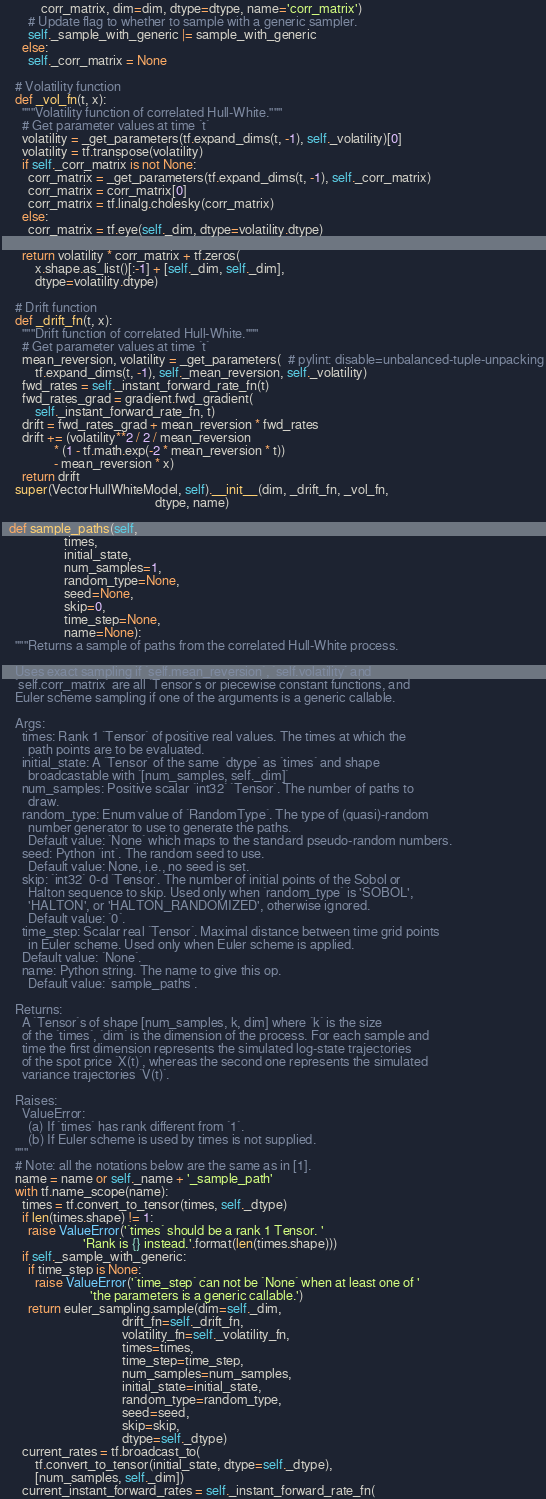<code> <loc_0><loc_0><loc_500><loc_500><_Python_>            corr_matrix, dim=dim, dtype=dtype, name='corr_matrix')
        # Update flag to whether to sample with a generic sampler.
        self._sample_with_generic |= sample_with_generic
      else:
        self._corr_matrix = None

    # Volatility function
    def _vol_fn(t, x):
      """Volatility function of correlated Hull-White."""
      # Get parameter values at time `t`
      volatility = _get_parameters(tf.expand_dims(t, -1), self._volatility)[0]
      volatility = tf.transpose(volatility)
      if self._corr_matrix is not None:
        corr_matrix = _get_parameters(tf.expand_dims(t, -1), self._corr_matrix)
        corr_matrix = corr_matrix[0]
        corr_matrix = tf.linalg.cholesky(corr_matrix)
      else:
        corr_matrix = tf.eye(self._dim, dtype=volatility.dtype)

      return volatility * corr_matrix + tf.zeros(
          x.shape.as_list()[:-1] + [self._dim, self._dim],
          dtype=volatility.dtype)

    # Drift function
    def _drift_fn(t, x):
      """Drift function of correlated Hull-White."""
      # Get parameter values at time `t`
      mean_reversion, volatility = _get_parameters(  # pylint: disable=unbalanced-tuple-unpacking
          tf.expand_dims(t, -1), self._mean_reversion, self._volatility)
      fwd_rates = self._instant_forward_rate_fn(t)
      fwd_rates_grad = gradient.fwd_gradient(
          self._instant_forward_rate_fn, t)
      drift = fwd_rates_grad + mean_reversion * fwd_rates
      drift += (volatility**2 / 2 / mean_reversion
                * (1 - tf.math.exp(-2 * mean_reversion * t))
                - mean_reversion * x)
      return drift
    super(VectorHullWhiteModel, self).__init__(dim, _drift_fn, _vol_fn,
                                               dtype, name)

  def sample_paths(self,
                   times,
                   initial_state,
                   num_samples=1,
                   random_type=None,
                   seed=None,
                   skip=0,
                   time_step=None,
                   name=None):
    """Returns a sample of paths from the correlated Hull-White process.

    Uses exact sampling if `self.mean_reversion`, `self.volatility` and
    `self.corr_matrix` are all `Tensor`s or piecewise constant functions, and
    Euler scheme sampling if one of the arguments is a generic callable.

    Args:
      times: Rank 1 `Tensor` of positive real values. The times at which the
        path points are to be evaluated.
      initial_state: A `Tensor` of the same `dtype` as `times` and shape
        broadcastable with `[num_samples, self._dim]`
      num_samples: Positive scalar `int32` `Tensor`. The number of paths to
        draw.
      random_type: Enum value of `RandomType`. The type of (quasi)-random
        number generator to use to generate the paths.
        Default value: `None` which maps to the standard pseudo-random numbers.
      seed: Python `int`. The random seed to use.
        Default value: None, i.e., no seed is set.
      skip: `int32` 0-d `Tensor`. The number of initial points of the Sobol or
        Halton sequence to skip. Used only when `random_type` is 'SOBOL',
        'HALTON', or 'HALTON_RANDOMIZED', otherwise ignored.
        Default value: `0`.
      time_step: Scalar real `Tensor`. Maximal distance between time grid points
        in Euler scheme. Used only when Euler scheme is applied.
      Default value: `None`.
      name: Python string. The name to give this op.
        Default value: `sample_paths`.

    Returns:
      A `Tensor`s of shape [num_samples, k, dim] where `k` is the size
      of the `times`, `dim` is the dimension of the process. For each sample and
      time the first dimension represents the simulated log-state trajectories
      of the spot price `X(t)`, whereas the second one represents the simulated
      variance trajectories `V(t)`.

    Raises:
      ValueError:
        (a) If `times` has rank different from `1`.
        (b) If Euler scheme is used by times is not supplied.
    """
    # Note: all the notations below are the same as in [1].
    name = name or self._name + '_sample_path'
    with tf.name_scope(name):
      times = tf.convert_to_tensor(times, self._dtype)
      if len(times.shape) != 1:
        raise ValueError('`times` should be a rank 1 Tensor. '
                         'Rank is {} instead.'.format(len(times.shape)))
      if self._sample_with_generic:
        if time_step is None:
          raise ValueError('`time_step` can not be `None` when at least one of '
                           'the parameters is a generic callable.')
        return euler_sampling.sample(dim=self._dim,
                                     drift_fn=self._drift_fn,
                                     volatility_fn=self._volatility_fn,
                                     times=times,
                                     time_step=time_step,
                                     num_samples=num_samples,
                                     initial_state=initial_state,
                                     random_type=random_type,
                                     seed=seed,
                                     skip=skip,
                                     dtype=self._dtype)
      current_rates = tf.broadcast_to(
          tf.convert_to_tensor(initial_state, dtype=self._dtype),
          [num_samples, self._dim])
      current_instant_forward_rates = self._instant_forward_rate_fn(</code> 